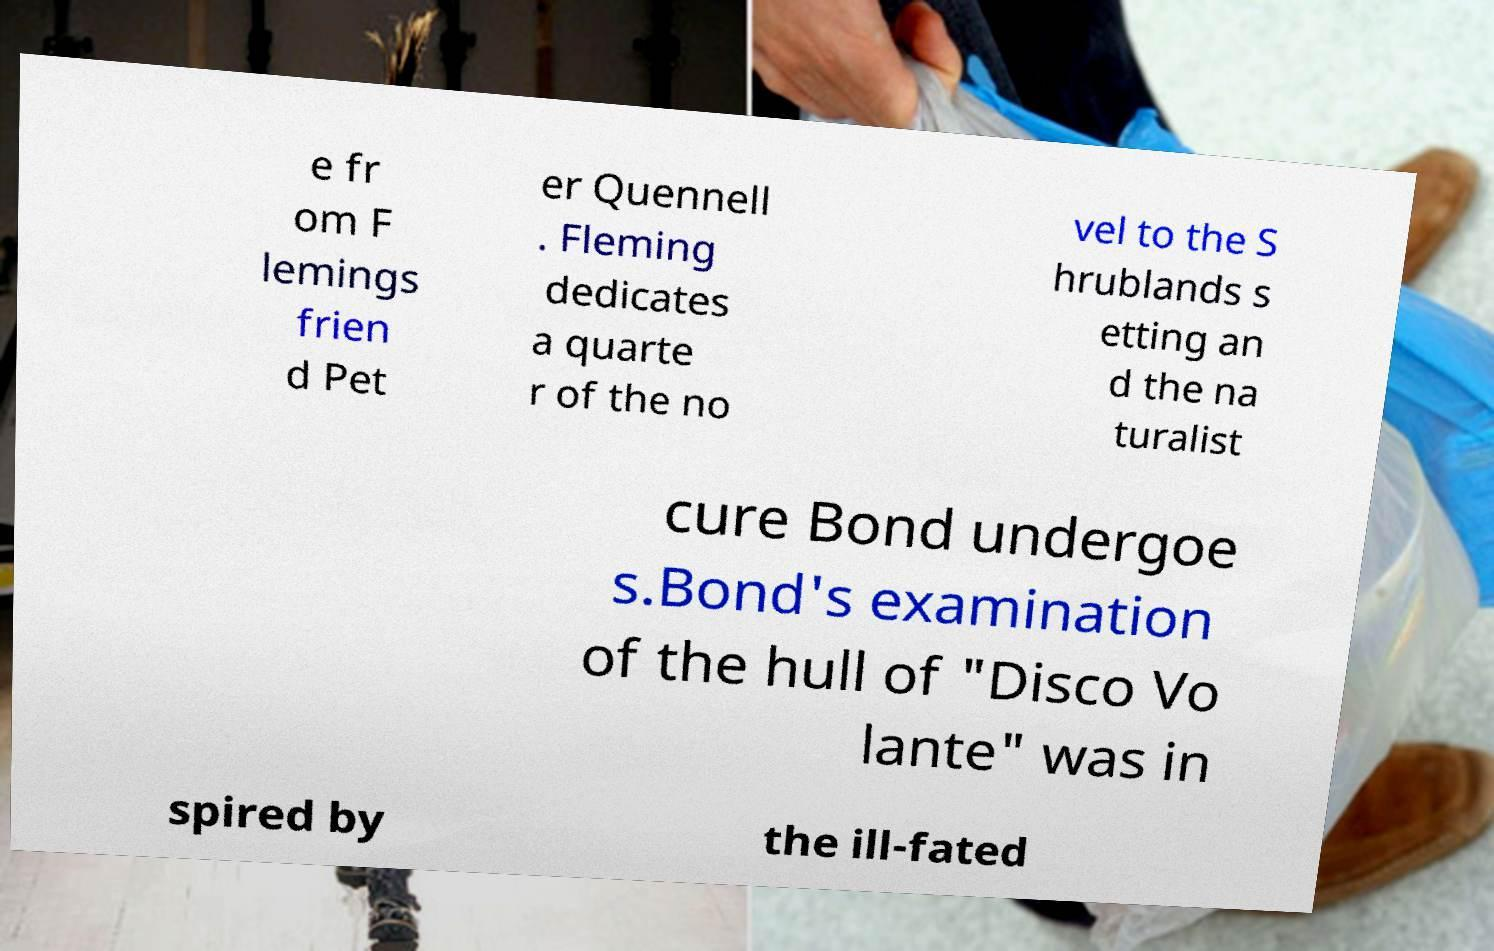Please identify and transcribe the text found in this image. e fr om F lemings frien d Pet er Quennell . Fleming dedicates a quarte r of the no vel to the S hrublands s etting an d the na turalist cure Bond undergoe s.Bond's examination of the hull of "Disco Vo lante" was in spired by the ill-fated 